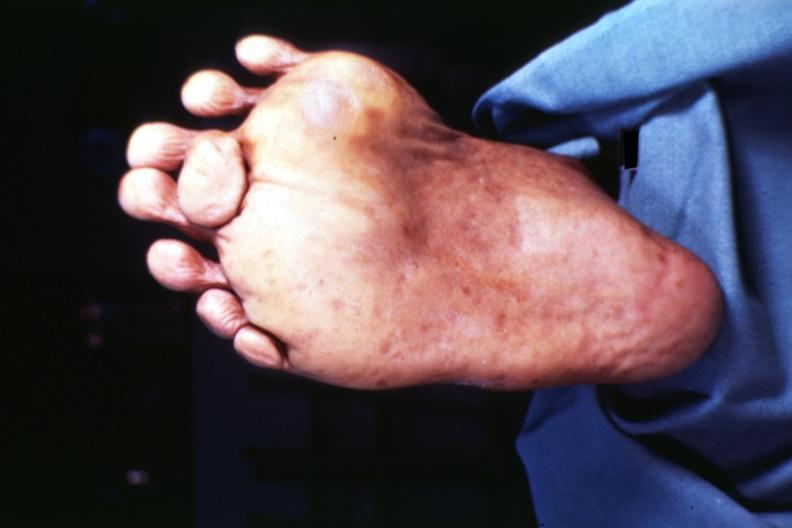does this image show view of foot from plantar surface 7 toes at least?
Answer the question using a single word or phrase. Yes 